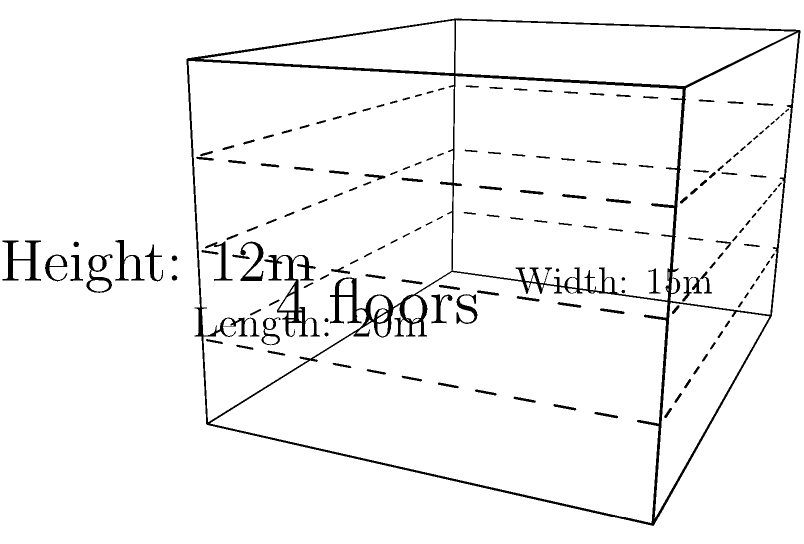A multicultural community center is planning to construct a new rectangular building with multiple floors to accommodate various services and activities. The building will have a length of 20 meters, a width of 15 meters, and a total height of 12 meters, divided into 4 floors of equal height. What is the total surface area of the building, including the roof and floor, that needs to be considered for construction and maintenance purposes? To calculate the total surface area of the building, we need to consider all external surfaces:

1. Calculate the area of the roof and floor:
   $A_{roof} = A_{floor} = length \times width = 20 \text{ m} \times 15 \text{ m} = 300 \text{ m}^2$

2. Calculate the area of the front and back walls:
   $A_{front} = A_{back} = length \times height = 20 \text{ m} \times 12 \text{ m} = 240 \text{ m}^2$

3. Calculate the area of the side walls:
   $A_{side} = width \times height = 15 \text{ m} \times 12 \text{ m} = 180 \text{ m}^2$

4. Sum up all the surfaces:
   $A_{total} = A_{roof} + A_{floor} + 2 \times A_{front} + 2 \times A_{side}$
   $A_{total} = 300 \text{ m}^2 + 300 \text{ m}^2 + 2 \times 240 \text{ m}^2 + 2 \times 180 \text{ m}^2$
   $A_{total} = 600 \text{ m}^2 + 480 \text{ m}^2 + 360 \text{ m}^2 = 1440 \text{ m}^2$

Therefore, the total surface area of the building is 1440 square meters.
Answer: 1440 m² 